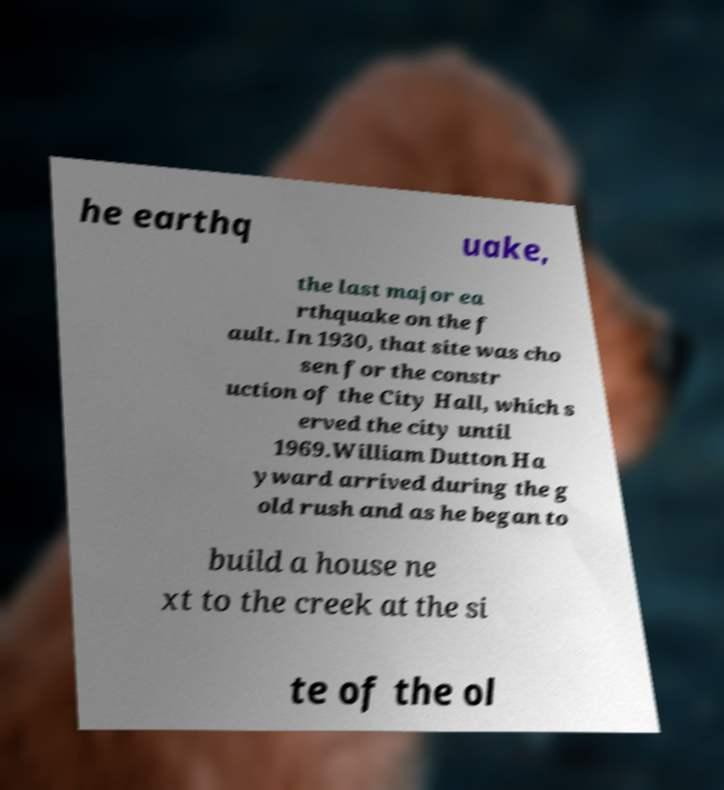I need the written content from this picture converted into text. Can you do that? he earthq uake, the last major ea rthquake on the f ault. In 1930, that site was cho sen for the constr uction of the City Hall, which s erved the city until 1969.William Dutton Ha yward arrived during the g old rush and as he began to build a house ne xt to the creek at the si te of the ol 